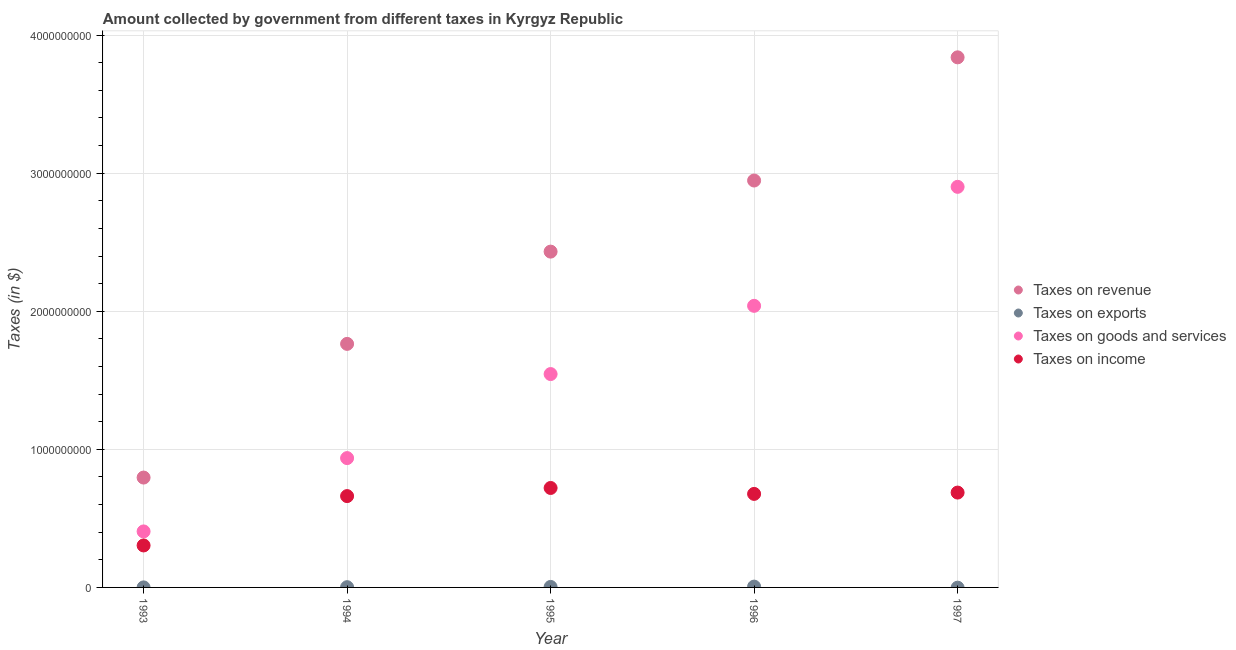What is the amount collected as tax on exports in 1995?
Your answer should be very brief. 3.56e+06. Across all years, what is the maximum amount collected as tax on goods?
Your answer should be compact. 2.90e+09. Across all years, what is the minimum amount collected as tax on exports?
Offer a terse response. 0. In which year was the amount collected as tax on goods maximum?
Provide a short and direct response. 1997. What is the total amount collected as tax on exports in the graph?
Provide a short and direct response. 1.14e+07. What is the difference between the amount collected as tax on revenue in 1993 and that in 1994?
Make the answer very short. -9.68e+08. What is the difference between the amount collected as tax on revenue in 1996 and the amount collected as tax on income in 1995?
Ensure brevity in your answer.  2.23e+09. What is the average amount collected as tax on income per year?
Offer a terse response. 6.10e+08. In the year 1996, what is the difference between the amount collected as tax on income and amount collected as tax on goods?
Your answer should be compact. -1.36e+09. What is the ratio of the amount collected as tax on exports in 1993 to that in 1995?
Your answer should be very brief. 0.04. Is the amount collected as tax on income in 1995 less than that in 1996?
Keep it short and to the point. No. Is the difference between the amount collected as tax on revenue in 1993 and 1994 greater than the difference between the amount collected as tax on exports in 1993 and 1994?
Your answer should be compact. No. What is the difference between the highest and the second highest amount collected as tax on income?
Offer a terse response. 3.33e+07. What is the difference between the highest and the lowest amount collected as tax on revenue?
Offer a terse response. 3.04e+09. In how many years, is the amount collected as tax on revenue greater than the average amount collected as tax on revenue taken over all years?
Your response must be concise. 3. Is the sum of the amount collected as tax on income in 1994 and 1997 greater than the maximum amount collected as tax on goods across all years?
Offer a very short reply. No. Is it the case that in every year, the sum of the amount collected as tax on exports and amount collected as tax on income is greater than the sum of amount collected as tax on goods and amount collected as tax on revenue?
Your answer should be very brief. Yes. Is it the case that in every year, the sum of the amount collected as tax on revenue and amount collected as tax on exports is greater than the amount collected as tax on goods?
Offer a very short reply. Yes. Does the amount collected as tax on revenue monotonically increase over the years?
Give a very brief answer. Yes. Is the amount collected as tax on exports strictly less than the amount collected as tax on revenue over the years?
Provide a succinct answer. Yes. How many dotlines are there?
Provide a succinct answer. 4. Are the values on the major ticks of Y-axis written in scientific E-notation?
Provide a short and direct response. No. How many legend labels are there?
Provide a short and direct response. 4. How are the legend labels stacked?
Give a very brief answer. Vertical. What is the title of the graph?
Provide a succinct answer. Amount collected by government from different taxes in Kyrgyz Republic. What is the label or title of the Y-axis?
Provide a short and direct response. Taxes (in $). What is the Taxes (in $) of Taxes on revenue in 1993?
Give a very brief answer. 7.96e+08. What is the Taxes (in $) of Taxes on exports in 1993?
Give a very brief answer. 1.46e+05. What is the Taxes (in $) of Taxes on goods and services in 1993?
Keep it short and to the point. 4.06e+08. What is the Taxes (in $) of Taxes on income in 1993?
Offer a terse response. 3.04e+08. What is the Taxes (in $) in Taxes on revenue in 1994?
Ensure brevity in your answer.  1.76e+09. What is the Taxes (in $) of Taxes on exports in 1994?
Your response must be concise. 1.81e+06. What is the Taxes (in $) in Taxes on goods and services in 1994?
Offer a very short reply. 9.37e+08. What is the Taxes (in $) of Taxes on income in 1994?
Your response must be concise. 6.62e+08. What is the Taxes (in $) in Taxes on revenue in 1995?
Offer a very short reply. 2.43e+09. What is the Taxes (in $) in Taxes on exports in 1995?
Your response must be concise. 3.56e+06. What is the Taxes (in $) of Taxes on goods and services in 1995?
Give a very brief answer. 1.55e+09. What is the Taxes (in $) in Taxes on income in 1995?
Provide a short and direct response. 7.20e+08. What is the Taxes (in $) in Taxes on revenue in 1996?
Keep it short and to the point. 2.95e+09. What is the Taxes (in $) of Taxes on exports in 1996?
Provide a short and direct response. 5.91e+06. What is the Taxes (in $) of Taxes on goods and services in 1996?
Provide a succinct answer. 2.04e+09. What is the Taxes (in $) of Taxes on income in 1996?
Ensure brevity in your answer.  6.77e+08. What is the Taxes (in $) of Taxes on revenue in 1997?
Offer a terse response. 3.84e+09. What is the Taxes (in $) of Taxes on goods and services in 1997?
Make the answer very short. 2.90e+09. What is the Taxes (in $) of Taxes on income in 1997?
Offer a very short reply. 6.87e+08. Across all years, what is the maximum Taxes (in $) of Taxes on revenue?
Offer a very short reply. 3.84e+09. Across all years, what is the maximum Taxes (in $) of Taxes on exports?
Provide a short and direct response. 5.91e+06. Across all years, what is the maximum Taxes (in $) of Taxes on goods and services?
Provide a succinct answer. 2.90e+09. Across all years, what is the maximum Taxes (in $) of Taxes on income?
Give a very brief answer. 7.20e+08. Across all years, what is the minimum Taxes (in $) of Taxes on revenue?
Give a very brief answer. 7.96e+08. Across all years, what is the minimum Taxes (in $) of Taxes on exports?
Make the answer very short. 0. Across all years, what is the minimum Taxes (in $) in Taxes on goods and services?
Keep it short and to the point. 4.06e+08. Across all years, what is the minimum Taxes (in $) of Taxes on income?
Ensure brevity in your answer.  3.04e+08. What is the total Taxes (in $) of Taxes on revenue in the graph?
Provide a succinct answer. 1.18e+1. What is the total Taxes (in $) of Taxes on exports in the graph?
Provide a short and direct response. 1.14e+07. What is the total Taxes (in $) in Taxes on goods and services in the graph?
Give a very brief answer. 7.83e+09. What is the total Taxes (in $) in Taxes on income in the graph?
Your response must be concise. 3.05e+09. What is the difference between the Taxes (in $) in Taxes on revenue in 1993 and that in 1994?
Your answer should be compact. -9.68e+08. What is the difference between the Taxes (in $) of Taxes on exports in 1993 and that in 1994?
Give a very brief answer. -1.66e+06. What is the difference between the Taxes (in $) in Taxes on goods and services in 1993 and that in 1994?
Keep it short and to the point. -5.31e+08. What is the difference between the Taxes (in $) in Taxes on income in 1993 and that in 1994?
Give a very brief answer. -3.58e+08. What is the difference between the Taxes (in $) in Taxes on revenue in 1993 and that in 1995?
Provide a succinct answer. -1.64e+09. What is the difference between the Taxes (in $) in Taxes on exports in 1993 and that in 1995?
Your response must be concise. -3.42e+06. What is the difference between the Taxes (in $) in Taxes on goods and services in 1993 and that in 1995?
Your response must be concise. -1.14e+09. What is the difference between the Taxes (in $) in Taxes on income in 1993 and that in 1995?
Ensure brevity in your answer.  -4.16e+08. What is the difference between the Taxes (in $) of Taxes on revenue in 1993 and that in 1996?
Your response must be concise. -2.15e+09. What is the difference between the Taxes (in $) of Taxes on exports in 1993 and that in 1996?
Your answer should be compact. -5.77e+06. What is the difference between the Taxes (in $) in Taxes on goods and services in 1993 and that in 1996?
Your answer should be very brief. -1.63e+09. What is the difference between the Taxes (in $) of Taxes on income in 1993 and that in 1996?
Offer a very short reply. -3.73e+08. What is the difference between the Taxes (in $) in Taxes on revenue in 1993 and that in 1997?
Your answer should be compact. -3.04e+09. What is the difference between the Taxes (in $) of Taxes on goods and services in 1993 and that in 1997?
Offer a terse response. -2.50e+09. What is the difference between the Taxes (in $) in Taxes on income in 1993 and that in 1997?
Provide a succinct answer. -3.83e+08. What is the difference between the Taxes (in $) in Taxes on revenue in 1994 and that in 1995?
Offer a terse response. -6.68e+08. What is the difference between the Taxes (in $) of Taxes on exports in 1994 and that in 1995?
Keep it short and to the point. -1.76e+06. What is the difference between the Taxes (in $) of Taxes on goods and services in 1994 and that in 1995?
Keep it short and to the point. -6.09e+08. What is the difference between the Taxes (in $) in Taxes on income in 1994 and that in 1995?
Offer a very short reply. -5.88e+07. What is the difference between the Taxes (in $) in Taxes on revenue in 1994 and that in 1996?
Offer a very short reply. -1.18e+09. What is the difference between the Taxes (in $) in Taxes on exports in 1994 and that in 1996?
Provide a short and direct response. -4.11e+06. What is the difference between the Taxes (in $) in Taxes on goods and services in 1994 and that in 1996?
Offer a terse response. -1.10e+09. What is the difference between the Taxes (in $) of Taxes on income in 1994 and that in 1996?
Provide a succinct answer. -1.59e+07. What is the difference between the Taxes (in $) in Taxes on revenue in 1994 and that in 1997?
Your answer should be very brief. -2.08e+09. What is the difference between the Taxes (in $) of Taxes on goods and services in 1994 and that in 1997?
Offer a terse response. -1.96e+09. What is the difference between the Taxes (in $) of Taxes on income in 1994 and that in 1997?
Keep it short and to the point. -2.55e+07. What is the difference between the Taxes (in $) of Taxes on revenue in 1995 and that in 1996?
Your answer should be compact. -5.15e+08. What is the difference between the Taxes (in $) of Taxes on exports in 1995 and that in 1996?
Your answer should be very brief. -2.35e+06. What is the difference between the Taxes (in $) of Taxes on goods and services in 1995 and that in 1996?
Offer a very short reply. -4.94e+08. What is the difference between the Taxes (in $) of Taxes on income in 1995 and that in 1996?
Keep it short and to the point. 4.29e+07. What is the difference between the Taxes (in $) of Taxes on revenue in 1995 and that in 1997?
Ensure brevity in your answer.  -1.41e+09. What is the difference between the Taxes (in $) in Taxes on goods and services in 1995 and that in 1997?
Offer a very short reply. -1.36e+09. What is the difference between the Taxes (in $) in Taxes on income in 1995 and that in 1997?
Offer a terse response. 3.33e+07. What is the difference between the Taxes (in $) of Taxes on revenue in 1996 and that in 1997?
Ensure brevity in your answer.  -8.92e+08. What is the difference between the Taxes (in $) of Taxes on goods and services in 1996 and that in 1997?
Give a very brief answer. -8.62e+08. What is the difference between the Taxes (in $) in Taxes on income in 1996 and that in 1997?
Your answer should be compact. -9.58e+06. What is the difference between the Taxes (in $) of Taxes on revenue in 1993 and the Taxes (in $) of Taxes on exports in 1994?
Your response must be concise. 7.94e+08. What is the difference between the Taxes (in $) of Taxes on revenue in 1993 and the Taxes (in $) of Taxes on goods and services in 1994?
Provide a succinct answer. -1.41e+08. What is the difference between the Taxes (in $) of Taxes on revenue in 1993 and the Taxes (in $) of Taxes on income in 1994?
Your response must be concise. 1.34e+08. What is the difference between the Taxes (in $) in Taxes on exports in 1993 and the Taxes (in $) in Taxes on goods and services in 1994?
Provide a succinct answer. -9.37e+08. What is the difference between the Taxes (in $) of Taxes on exports in 1993 and the Taxes (in $) of Taxes on income in 1994?
Provide a short and direct response. -6.61e+08. What is the difference between the Taxes (in $) of Taxes on goods and services in 1993 and the Taxes (in $) of Taxes on income in 1994?
Offer a very short reply. -2.56e+08. What is the difference between the Taxes (in $) of Taxes on revenue in 1993 and the Taxes (in $) of Taxes on exports in 1995?
Keep it short and to the point. 7.92e+08. What is the difference between the Taxes (in $) in Taxes on revenue in 1993 and the Taxes (in $) in Taxes on goods and services in 1995?
Your answer should be very brief. -7.50e+08. What is the difference between the Taxes (in $) in Taxes on revenue in 1993 and the Taxes (in $) in Taxes on income in 1995?
Provide a succinct answer. 7.54e+07. What is the difference between the Taxes (in $) in Taxes on exports in 1993 and the Taxes (in $) in Taxes on goods and services in 1995?
Offer a terse response. -1.55e+09. What is the difference between the Taxes (in $) of Taxes on exports in 1993 and the Taxes (in $) of Taxes on income in 1995?
Your response must be concise. -7.20e+08. What is the difference between the Taxes (in $) in Taxes on goods and services in 1993 and the Taxes (in $) in Taxes on income in 1995?
Make the answer very short. -3.15e+08. What is the difference between the Taxes (in $) in Taxes on revenue in 1993 and the Taxes (in $) in Taxes on exports in 1996?
Provide a succinct answer. 7.90e+08. What is the difference between the Taxes (in $) in Taxes on revenue in 1993 and the Taxes (in $) in Taxes on goods and services in 1996?
Provide a succinct answer. -1.24e+09. What is the difference between the Taxes (in $) of Taxes on revenue in 1993 and the Taxes (in $) of Taxes on income in 1996?
Your answer should be very brief. 1.18e+08. What is the difference between the Taxes (in $) of Taxes on exports in 1993 and the Taxes (in $) of Taxes on goods and services in 1996?
Offer a terse response. -2.04e+09. What is the difference between the Taxes (in $) in Taxes on exports in 1993 and the Taxes (in $) in Taxes on income in 1996?
Offer a terse response. -6.77e+08. What is the difference between the Taxes (in $) in Taxes on goods and services in 1993 and the Taxes (in $) in Taxes on income in 1996?
Provide a short and direct response. -2.72e+08. What is the difference between the Taxes (in $) of Taxes on revenue in 1993 and the Taxes (in $) of Taxes on goods and services in 1997?
Provide a short and direct response. -2.11e+09. What is the difference between the Taxes (in $) in Taxes on revenue in 1993 and the Taxes (in $) in Taxes on income in 1997?
Provide a short and direct response. 1.09e+08. What is the difference between the Taxes (in $) of Taxes on exports in 1993 and the Taxes (in $) of Taxes on goods and services in 1997?
Your answer should be compact. -2.90e+09. What is the difference between the Taxes (in $) in Taxes on exports in 1993 and the Taxes (in $) in Taxes on income in 1997?
Your response must be concise. -6.87e+08. What is the difference between the Taxes (in $) in Taxes on goods and services in 1993 and the Taxes (in $) in Taxes on income in 1997?
Your response must be concise. -2.81e+08. What is the difference between the Taxes (in $) of Taxes on revenue in 1994 and the Taxes (in $) of Taxes on exports in 1995?
Your response must be concise. 1.76e+09. What is the difference between the Taxes (in $) of Taxes on revenue in 1994 and the Taxes (in $) of Taxes on goods and services in 1995?
Make the answer very short. 2.19e+08. What is the difference between the Taxes (in $) of Taxes on revenue in 1994 and the Taxes (in $) of Taxes on income in 1995?
Your answer should be compact. 1.04e+09. What is the difference between the Taxes (in $) of Taxes on exports in 1994 and the Taxes (in $) of Taxes on goods and services in 1995?
Provide a short and direct response. -1.54e+09. What is the difference between the Taxes (in $) of Taxes on exports in 1994 and the Taxes (in $) of Taxes on income in 1995?
Give a very brief answer. -7.18e+08. What is the difference between the Taxes (in $) in Taxes on goods and services in 1994 and the Taxes (in $) in Taxes on income in 1995?
Your answer should be very brief. 2.16e+08. What is the difference between the Taxes (in $) in Taxes on revenue in 1994 and the Taxes (in $) in Taxes on exports in 1996?
Offer a very short reply. 1.76e+09. What is the difference between the Taxes (in $) in Taxes on revenue in 1994 and the Taxes (in $) in Taxes on goods and services in 1996?
Provide a short and direct response. -2.76e+08. What is the difference between the Taxes (in $) in Taxes on revenue in 1994 and the Taxes (in $) in Taxes on income in 1996?
Ensure brevity in your answer.  1.09e+09. What is the difference between the Taxes (in $) of Taxes on exports in 1994 and the Taxes (in $) of Taxes on goods and services in 1996?
Your answer should be compact. -2.04e+09. What is the difference between the Taxes (in $) of Taxes on exports in 1994 and the Taxes (in $) of Taxes on income in 1996?
Your response must be concise. -6.76e+08. What is the difference between the Taxes (in $) of Taxes on goods and services in 1994 and the Taxes (in $) of Taxes on income in 1996?
Your response must be concise. 2.59e+08. What is the difference between the Taxes (in $) in Taxes on revenue in 1994 and the Taxes (in $) in Taxes on goods and services in 1997?
Offer a very short reply. -1.14e+09. What is the difference between the Taxes (in $) in Taxes on revenue in 1994 and the Taxes (in $) in Taxes on income in 1997?
Keep it short and to the point. 1.08e+09. What is the difference between the Taxes (in $) of Taxes on exports in 1994 and the Taxes (in $) of Taxes on goods and services in 1997?
Offer a very short reply. -2.90e+09. What is the difference between the Taxes (in $) of Taxes on exports in 1994 and the Taxes (in $) of Taxes on income in 1997?
Offer a terse response. -6.85e+08. What is the difference between the Taxes (in $) in Taxes on goods and services in 1994 and the Taxes (in $) in Taxes on income in 1997?
Keep it short and to the point. 2.50e+08. What is the difference between the Taxes (in $) of Taxes on revenue in 1995 and the Taxes (in $) of Taxes on exports in 1996?
Your answer should be very brief. 2.43e+09. What is the difference between the Taxes (in $) in Taxes on revenue in 1995 and the Taxes (in $) in Taxes on goods and services in 1996?
Offer a terse response. 3.93e+08. What is the difference between the Taxes (in $) of Taxes on revenue in 1995 and the Taxes (in $) of Taxes on income in 1996?
Give a very brief answer. 1.75e+09. What is the difference between the Taxes (in $) in Taxes on exports in 1995 and the Taxes (in $) in Taxes on goods and services in 1996?
Make the answer very short. -2.04e+09. What is the difference between the Taxes (in $) of Taxes on exports in 1995 and the Taxes (in $) of Taxes on income in 1996?
Provide a short and direct response. -6.74e+08. What is the difference between the Taxes (in $) in Taxes on goods and services in 1995 and the Taxes (in $) in Taxes on income in 1996?
Your answer should be compact. 8.68e+08. What is the difference between the Taxes (in $) of Taxes on revenue in 1995 and the Taxes (in $) of Taxes on goods and services in 1997?
Provide a short and direct response. -4.69e+08. What is the difference between the Taxes (in $) of Taxes on revenue in 1995 and the Taxes (in $) of Taxes on income in 1997?
Offer a very short reply. 1.75e+09. What is the difference between the Taxes (in $) in Taxes on exports in 1995 and the Taxes (in $) in Taxes on goods and services in 1997?
Offer a very short reply. -2.90e+09. What is the difference between the Taxes (in $) in Taxes on exports in 1995 and the Taxes (in $) in Taxes on income in 1997?
Make the answer very short. -6.83e+08. What is the difference between the Taxes (in $) of Taxes on goods and services in 1995 and the Taxes (in $) of Taxes on income in 1997?
Ensure brevity in your answer.  8.58e+08. What is the difference between the Taxes (in $) of Taxes on revenue in 1996 and the Taxes (in $) of Taxes on goods and services in 1997?
Offer a very short reply. 4.57e+07. What is the difference between the Taxes (in $) of Taxes on revenue in 1996 and the Taxes (in $) of Taxes on income in 1997?
Offer a very short reply. 2.26e+09. What is the difference between the Taxes (in $) in Taxes on exports in 1996 and the Taxes (in $) in Taxes on goods and services in 1997?
Provide a succinct answer. -2.90e+09. What is the difference between the Taxes (in $) in Taxes on exports in 1996 and the Taxes (in $) in Taxes on income in 1997?
Ensure brevity in your answer.  -6.81e+08. What is the difference between the Taxes (in $) in Taxes on goods and services in 1996 and the Taxes (in $) in Taxes on income in 1997?
Offer a very short reply. 1.35e+09. What is the average Taxes (in $) of Taxes on revenue per year?
Provide a succinct answer. 2.36e+09. What is the average Taxes (in $) in Taxes on exports per year?
Provide a succinct answer. 2.29e+06. What is the average Taxes (in $) of Taxes on goods and services per year?
Make the answer very short. 1.57e+09. What is the average Taxes (in $) in Taxes on income per year?
Your answer should be compact. 6.10e+08. In the year 1993, what is the difference between the Taxes (in $) of Taxes on revenue and Taxes (in $) of Taxes on exports?
Make the answer very short. 7.96e+08. In the year 1993, what is the difference between the Taxes (in $) in Taxes on revenue and Taxes (in $) in Taxes on goods and services?
Your answer should be very brief. 3.90e+08. In the year 1993, what is the difference between the Taxes (in $) of Taxes on revenue and Taxes (in $) of Taxes on income?
Give a very brief answer. 4.92e+08. In the year 1993, what is the difference between the Taxes (in $) of Taxes on exports and Taxes (in $) of Taxes on goods and services?
Keep it short and to the point. -4.05e+08. In the year 1993, what is the difference between the Taxes (in $) of Taxes on exports and Taxes (in $) of Taxes on income?
Your response must be concise. -3.04e+08. In the year 1993, what is the difference between the Taxes (in $) in Taxes on goods and services and Taxes (in $) in Taxes on income?
Provide a short and direct response. 1.02e+08. In the year 1994, what is the difference between the Taxes (in $) of Taxes on revenue and Taxes (in $) of Taxes on exports?
Ensure brevity in your answer.  1.76e+09. In the year 1994, what is the difference between the Taxes (in $) of Taxes on revenue and Taxes (in $) of Taxes on goods and services?
Your response must be concise. 8.27e+08. In the year 1994, what is the difference between the Taxes (in $) in Taxes on revenue and Taxes (in $) in Taxes on income?
Make the answer very short. 1.10e+09. In the year 1994, what is the difference between the Taxes (in $) in Taxes on exports and Taxes (in $) in Taxes on goods and services?
Provide a succinct answer. -9.35e+08. In the year 1994, what is the difference between the Taxes (in $) of Taxes on exports and Taxes (in $) of Taxes on income?
Offer a terse response. -6.60e+08. In the year 1994, what is the difference between the Taxes (in $) of Taxes on goods and services and Taxes (in $) of Taxes on income?
Ensure brevity in your answer.  2.75e+08. In the year 1995, what is the difference between the Taxes (in $) of Taxes on revenue and Taxes (in $) of Taxes on exports?
Give a very brief answer. 2.43e+09. In the year 1995, what is the difference between the Taxes (in $) of Taxes on revenue and Taxes (in $) of Taxes on goods and services?
Keep it short and to the point. 8.87e+08. In the year 1995, what is the difference between the Taxes (in $) in Taxes on revenue and Taxes (in $) in Taxes on income?
Give a very brief answer. 1.71e+09. In the year 1995, what is the difference between the Taxes (in $) of Taxes on exports and Taxes (in $) of Taxes on goods and services?
Ensure brevity in your answer.  -1.54e+09. In the year 1995, what is the difference between the Taxes (in $) of Taxes on exports and Taxes (in $) of Taxes on income?
Offer a very short reply. -7.17e+08. In the year 1995, what is the difference between the Taxes (in $) in Taxes on goods and services and Taxes (in $) in Taxes on income?
Offer a terse response. 8.25e+08. In the year 1996, what is the difference between the Taxes (in $) in Taxes on revenue and Taxes (in $) in Taxes on exports?
Ensure brevity in your answer.  2.94e+09. In the year 1996, what is the difference between the Taxes (in $) of Taxes on revenue and Taxes (in $) of Taxes on goods and services?
Offer a terse response. 9.08e+08. In the year 1996, what is the difference between the Taxes (in $) of Taxes on revenue and Taxes (in $) of Taxes on income?
Provide a succinct answer. 2.27e+09. In the year 1996, what is the difference between the Taxes (in $) in Taxes on exports and Taxes (in $) in Taxes on goods and services?
Offer a terse response. -2.03e+09. In the year 1996, what is the difference between the Taxes (in $) in Taxes on exports and Taxes (in $) in Taxes on income?
Make the answer very short. -6.71e+08. In the year 1996, what is the difference between the Taxes (in $) in Taxes on goods and services and Taxes (in $) in Taxes on income?
Offer a very short reply. 1.36e+09. In the year 1997, what is the difference between the Taxes (in $) in Taxes on revenue and Taxes (in $) in Taxes on goods and services?
Make the answer very short. 9.38e+08. In the year 1997, what is the difference between the Taxes (in $) of Taxes on revenue and Taxes (in $) of Taxes on income?
Provide a succinct answer. 3.15e+09. In the year 1997, what is the difference between the Taxes (in $) of Taxes on goods and services and Taxes (in $) of Taxes on income?
Your response must be concise. 2.21e+09. What is the ratio of the Taxes (in $) of Taxes on revenue in 1993 to that in 1994?
Your answer should be very brief. 0.45. What is the ratio of the Taxes (in $) of Taxes on exports in 1993 to that in 1994?
Provide a short and direct response. 0.08. What is the ratio of the Taxes (in $) of Taxes on goods and services in 1993 to that in 1994?
Make the answer very short. 0.43. What is the ratio of the Taxes (in $) of Taxes on income in 1993 to that in 1994?
Your answer should be compact. 0.46. What is the ratio of the Taxes (in $) in Taxes on revenue in 1993 to that in 1995?
Provide a succinct answer. 0.33. What is the ratio of the Taxes (in $) in Taxes on exports in 1993 to that in 1995?
Your answer should be very brief. 0.04. What is the ratio of the Taxes (in $) of Taxes on goods and services in 1993 to that in 1995?
Offer a terse response. 0.26. What is the ratio of the Taxes (in $) in Taxes on income in 1993 to that in 1995?
Your answer should be compact. 0.42. What is the ratio of the Taxes (in $) in Taxes on revenue in 1993 to that in 1996?
Keep it short and to the point. 0.27. What is the ratio of the Taxes (in $) in Taxes on exports in 1993 to that in 1996?
Offer a terse response. 0.02. What is the ratio of the Taxes (in $) in Taxes on goods and services in 1993 to that in 1996?
Your answer should be very brief. 0.2. What is the ratio of the Taxes (in $) of Taxes on income in 1993 to that in 1996?
Keep it short and to the point. 0.45. What is the ratio of the Taxes (in $) in Taxes on revenue in 1993 to that in 1997?
Provide a short and direct response. 0.21. What is the ratio of the Taxes (in $) in Taxes on goods and services in 1993 to that in 1997?
Provide a short and direct response. 0.14. What is the ratio of the Taxes (in $) of Taxes on income in 1993 to that in 1997?
Offer a terse response. 0.44. What is the ratio of the Taxes (in $) of Taxes on revenue in 1994 to that in 1995?
Your answer should be very brief. 0.73. What is the ratio of the Taxes (in $) in Taxes on exports in 1994 to that in 1995?
Your answer should be compact. 0.51. What is the ratio of the Taxes (in $) in Taxes on goods and services in 1994 to that in 1995?
Ensure brevity in your answer.  0.61. What is the ratio of the Taxes (in $) of Taxes on income in 1994 to that in 1995?
Offer a terse response. 0.92. What is the ratio of the Taxes (in $) of Taxes on revenue in 1994 to that in 1996?
Keep it short and to the point. 0.6. What is the ratio of the Taxes (in $) of Taxes on exports in 1994 to that in 1996?
Your response must be concise. 0.31. What is the ratio of the Taxes (in $) in Taxes on goods and services in 1994 to that in 1996?
Give a very brief answer. 0.46. What is the ratio of the Taxes (in $) of Taxes on income in 1994 to that in 1996?
Your response must be concise. 0.98. What is the ratio of the Taxes (in $) in Taxes on revenue in 1994 to that in 1997?
Your response must be concise. 0.46. What is the ratio of the Taxes (in $) of Taxes on goods and services in 1994 to that in 1997?
Your response must be concise. 0.32. What is the ratio of the Taxes (in $) in Taxes on income in 1994 to that in 1997?
Ensure brevity in your answer.  0.96. What is the ratio of the Taxes (in $) of Taxes on revenue in 1995 to that in 1996?
Provide a succinct answer. 0.83. What is the ratio of the Taxes (in $) of Taxes on exports in 1995 to that in 1996?
Offer a terse response. 0.6. What is the ratio of the Taxes (in $) of Taxes on goods and services in 1995 to that in 1996?
Your response must be concise. 0.76. What is the ratio of the Taxes (in $) of Taxes on income in 1995 to that in 1996?
Your answer should be very brief. 1.06. What is the ratio of the Taxes (in $) in Taxes on revenue in 1995 to that in 1997?
Your answer should be very brief. 0.63. What is the ratio of the Taxes (in $) in Taxes on goods and services in 1995 to that in 1997?
Give a very brief answer. 0.53. What is the ratio of the Taxes (in $) of Taxes on income in 1995 to that in 1997?
Make the answer very short. 1.05. What is the ratio of the Taxes (in $) in Taxes on revenue in 1996 to that in 1997?
Keep it short and to the point. 0.77. What is the ratio of the Taxes (in $) of Taxes on goods and services in 1996 to that in 1997?
Your response must be concise. 0.7. What is the ratio of the Taxes (in $) in Taxes on income in 1996 to that in 1997?
Ensure brevity in your answer.  0.99. What is the difference between the highest and the second highest Taxes (in $) in Taxes on revenue?
Your answer should be very brief. 8.92e+08. What is the difference between the highest and the second highest Taxes (in $) of Taxes on exports?
Keep it short and to the point. 2.35e+06. What is the difference between the highest and the second highest Taxes (in $) in Taxes on goods and services?
Offer a terse response. 8.62e+08. What is the difference between the highest and the second highest Taxes (in $) of Taxes on income?
Your answer should be compact. 3.33e+07. What is the difference between the highest and the lowest Taxes (in $) of Taxes on revenue?
Keep it short and to the point. 3.04e+09. What is the difference between the highest and the lowest Taxes (in $) of Taxes on exports?
Offer a very short reply. 5.91e+06. What is the difference between the highest and the lowest Taxes (in $) in Taxes on goods and services?
Your response must be concise. 2.50e+09. What is the difference between the highest and the lowest Taxes (in $) of Taxes on income?
Your answer should be very brief. 4.16e+08. 